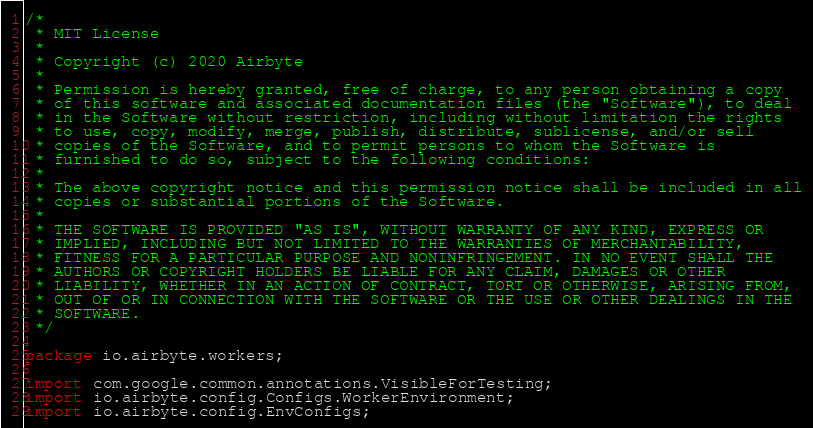Convert code to text. <code><loc_0><loc_0><loc_500><loc_500><_Java_>/*
 * MIT License
 *
 * Copyright (c) 2020 Airbyte
 *
 * Permission is hereby granted, free of charge, to any person obtaining a copy
 * of this software and associated documentation files (the "Software"), to deal
 * in the Software without restriction, including without limitation the rights
 * to use, copy, modify, merge, publish, distribute, sublicense, and/or sell
 * copies of the Software, and to permit persons to whom the Software is
 * furnished to do so, subject to the following conditions:
 *
 * The above copyright notice and this permission notice shall be included in all
 * copies or substantial portions of the Software.
 *
 * THE SOFTWARE IS PROVIDED "AS IS", WITHOUT WARRANTY OF ANY KIND, EXPRESS OR
 * IMPLIED, INCLUDING BUT NOT LIMITED TO THE WARRANTIES OF MERCHANTABILITY,
 * FITNESS FOR A PARTICULAR PURPOSE AND NONINFRINGEMENT. IN NO EVENT SHALL THE
 * AUTHORS OR COPYRIGHT HOLDERS BE LIABLE FOR ANY CLAIM, DAMAGES OR OTHER
 * LIABILITY, WHETHER IN AN ACTION OF CONTRACT, TORT OR OTHERWISE, ARISING FROM,
 * OUT OF OR IN CONNECTION WITH THE SOFTWARE OR THE USE OR OTHER DEALINGS IN THE
 * SOFTWARE.
 */

package io.airbyte.workers;

import com.google.common.annotations.VisibleForTesting;
import io.airbyte.config.Configs.WorkerEnvironment;
import io.airbyte.config.EnvConfigs;</code> 